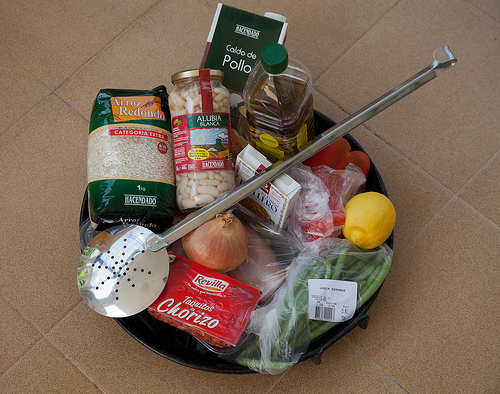<image>
Is there a onion under the bowl? No. The onion is not positioned under the bowl. The vertical relationship between these objects is different. Is the onion in the oil? No. The onion is not contained within the oil. These objects have a different spatial relationship. Where is the oil in relation to the spoon? Is it behind the spoon? Yes. From this viewpoint, the oil is positioned behind the spoon, with the spoon partially or fully occluding the oil. 